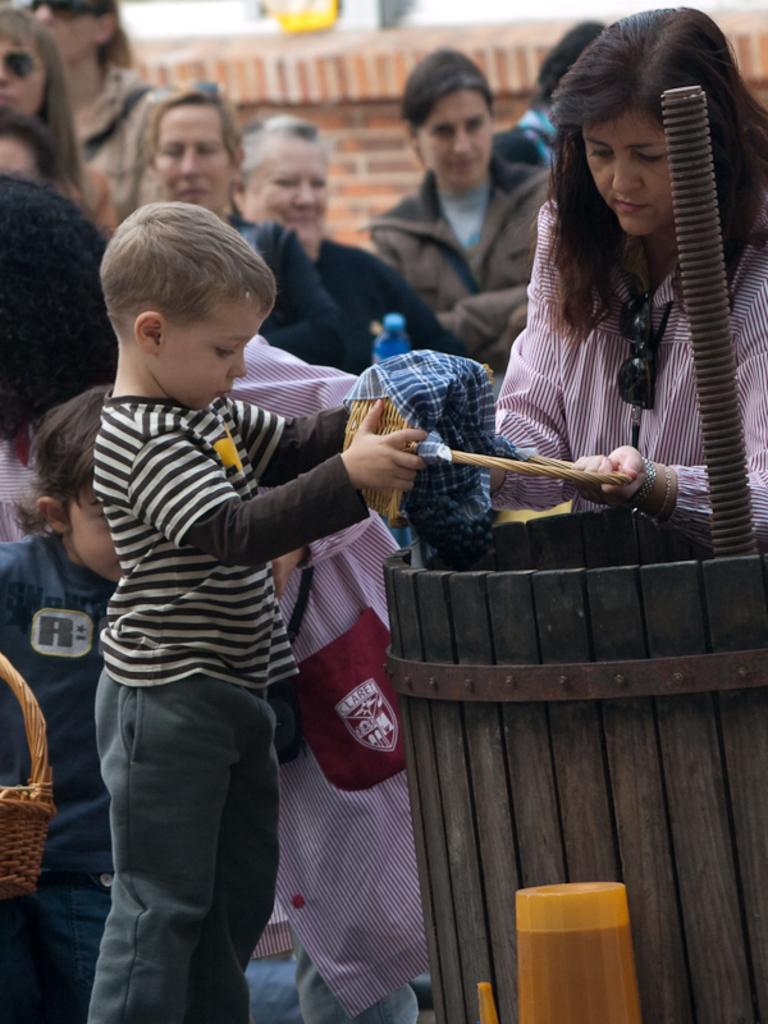What is happening in the image involving the people? There are people standing in the image, and they are holding objects. What can be seen in the background of the image? There is a wall in the image. What else is present in the image besides the people and the wall? There are objects on a surface in the image. How are the people folding the objects they are holding in the image? There is no indication in the image that the people are folding any objects; they are simply holding them. Are the people fighting with the objects they are holding in the image? There is no indication in the image that the people are fighting with the objects they are holding; they are simply holding them. 